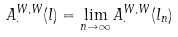<formula> <loc_0><loc_0><loc_500><loc_500>A ^ { W , W } _ { \cdot } ( l ) = \lim _ { n \to \infty } A _ { \cdot } ^ { W , W } ( l _ { n } )</formula> 